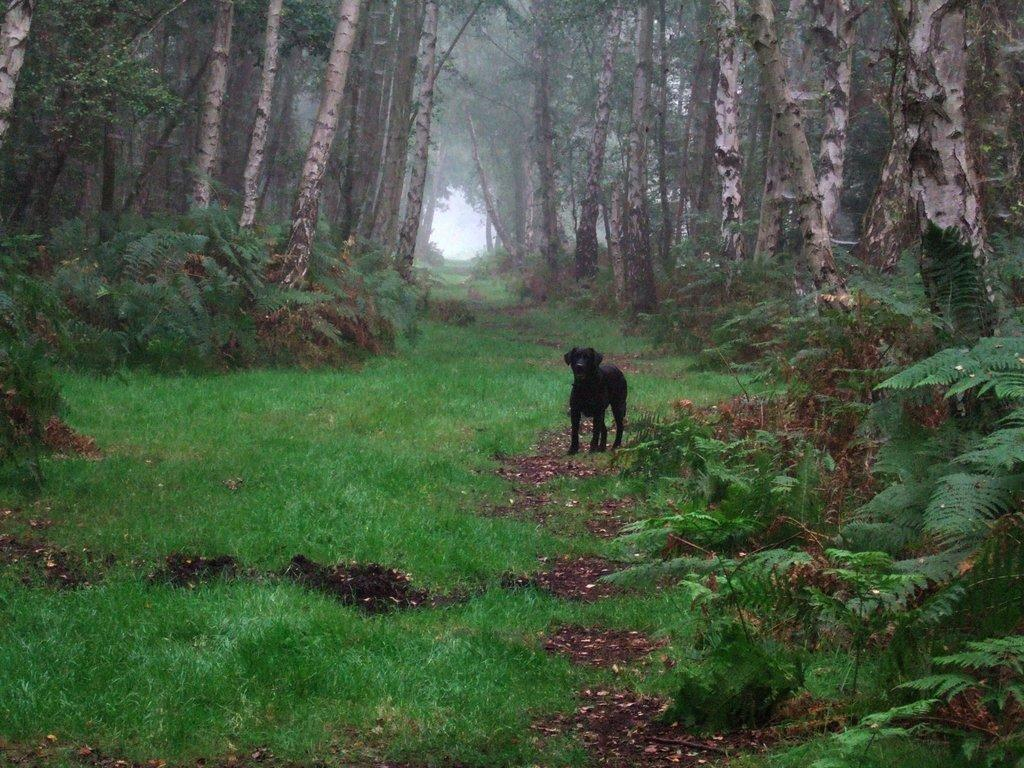What is the main subject in the center of the image? There is a black dog in the center of the image}. What can be seen in the background of the image? There are trees, smoke, plants, and grass visible in the background of the image. How many beds can be seen in the image? There are no beds present in the image. What type of arch is visible in the image? There is no arch present in the image. 